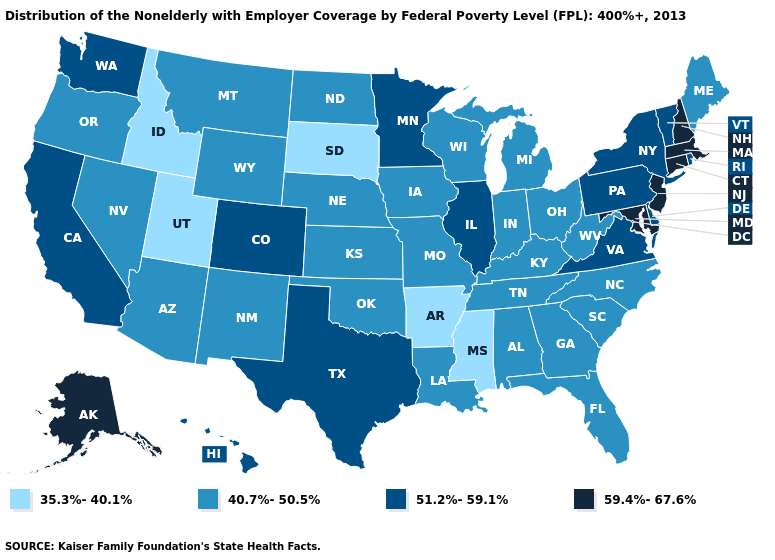Does Utah have the lowest value in the USA?
Answer briefly. Yes. Which states hav the highest value in the Northeast?
Short answer required. Connecticut, Massachusetts, New Hampshire, New Jersey. Among the states that border Indiana , does Illinois have the highest value?
Keep it brief. Yes. What is the lowest value in the MidWest?
Write a very short answer. 35.3%-40.1%. Which states have the lowest value in the USA?
Keep it brief. Arkansas, Idaho, Mississippi, South Dakota, Utah. Name the states that have a value in the range 35.3%-40.1%?
Write a very short answer. Arkansas, Idaho, Mississippi, South Dakota, Utah. Does the first symbol in the legend represent the smallest category?
Answer briefly. Yes. Does Tennessee have the same value as North Dakota?
Be succinct. Yes. Which states have the lowest value in the USA?
Quick response, please. Arkansas, Idaho, Mississippi, South Dakota, Utah. Does Washington have the lowest value in the West?
Short answer required. No. What is the highest value in the West ?
Short answer required. 59.4%-67.6%. Which states hav the highest value in the MidWest?
Be succinct. Illinois, Minnesota. Name the states that have a value in the range 40.7%-50.5%?
Keep it brief. Alabama, Arizona, Florida, Georgia, Indiana, Iowa, Kansas, Kentucky, Louisiana, Maine, Michigan, Missouri, Montana, Nebraska, Nevada, New Mexico, North Carolina, North Dakota, Ohio, Oklahoma, Oregon, South Carolina, Tennessee, West Virginia, Wisconsin, Wyoming. Name the states that have a value in the range 35.3%-40.1%?
Quick response, please. Arkansas, Idaho, Mississippi, South Dakota, Utah. Among the states that border Rhode Island , which have the lowest value?
Answer briefly. Connecticut, Massachusetts. 